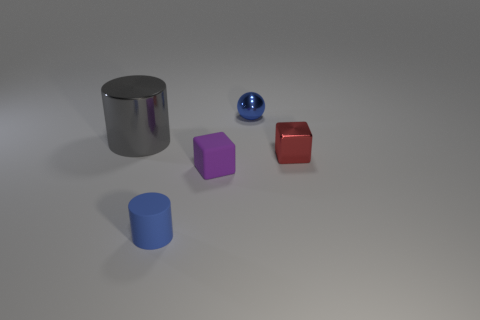Add 5 small gray metallic things. How many objects exist? 10 Subtract 0 yellow cubes. How many objects are left? 5 Subtract all spheres. How many objects are left? 4 Subtract all big gray shiny things. Subtract all blue matte cylinders. How many objects are left? 3 Add 2 purple things. How many purple things are left? 3 Add 1 small red blocks. How many small red blocks exist? 2 